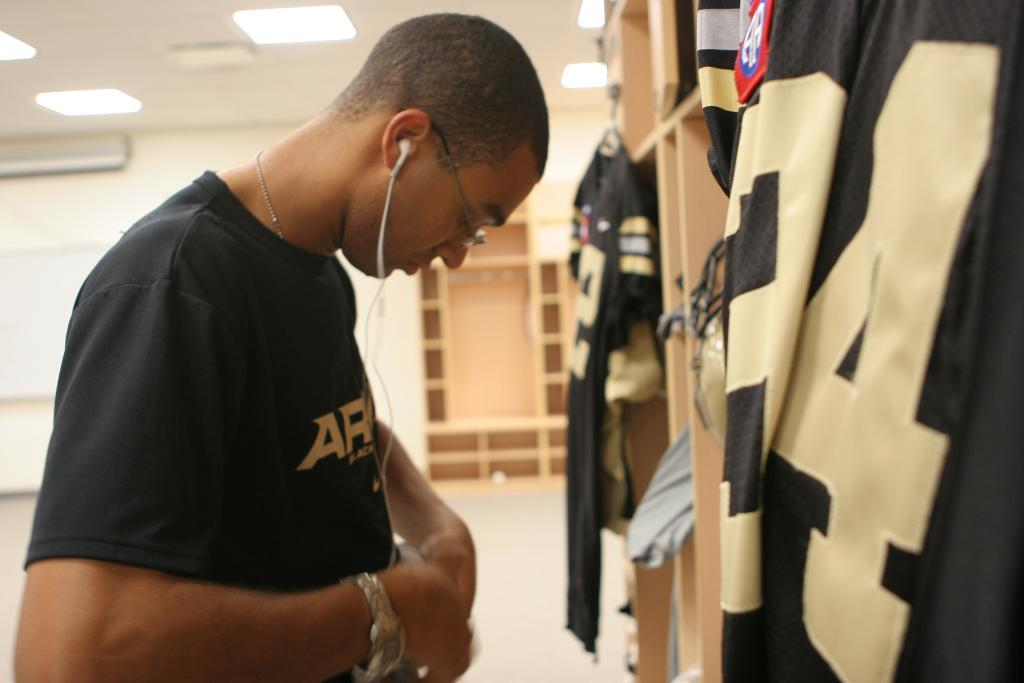Who is present in the image? There is a man in the image. What is the man wearing? The man is wearing clothes, a neck chain, spectacles, and a wrist watch. What accessories can be seen in the image? There are headsets in the image. What type of surface is visible in the image? There is a floor in the image. What type of furniture is present in the image? There is a shelf in the image. What source of illumination is visible in the image? There is a light in the image. What type of calendar is hanging on the wall in the image? There is no calendar present in the image. Does the man have a tail in the image? No, the man does not have a tail in the image. 